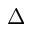<formula> <loc_0><loc_0><loc_500><loc_500>\Delta</formula> 